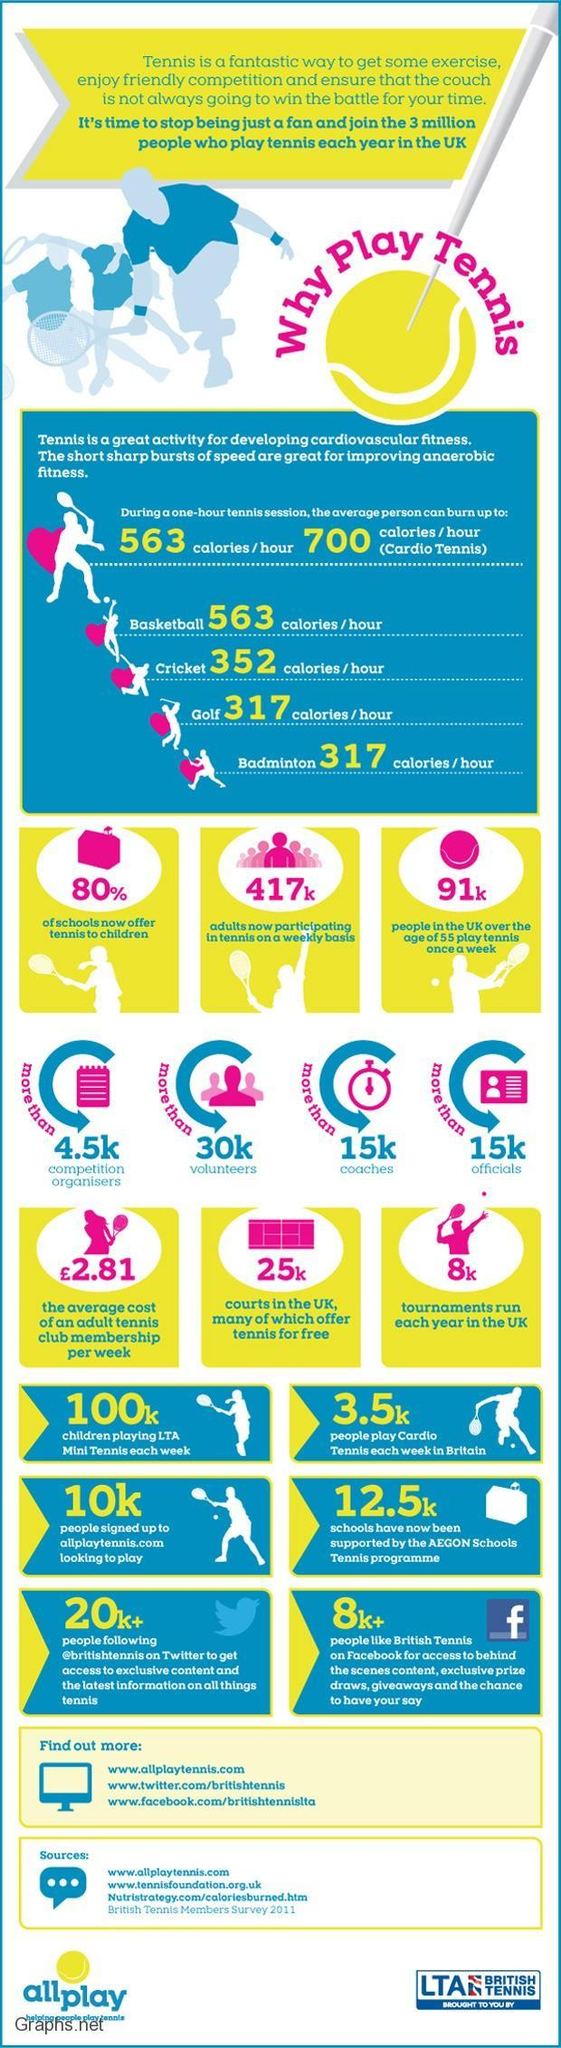What percentage of schools are not offering tennis to children?
Answer the question with a short phrase. 20% How many adults are participating in tennis every week? 417k How many people play cardio tennis each week in Britain? 3.5k How many people signed up to allplaytennis.com? 10k 